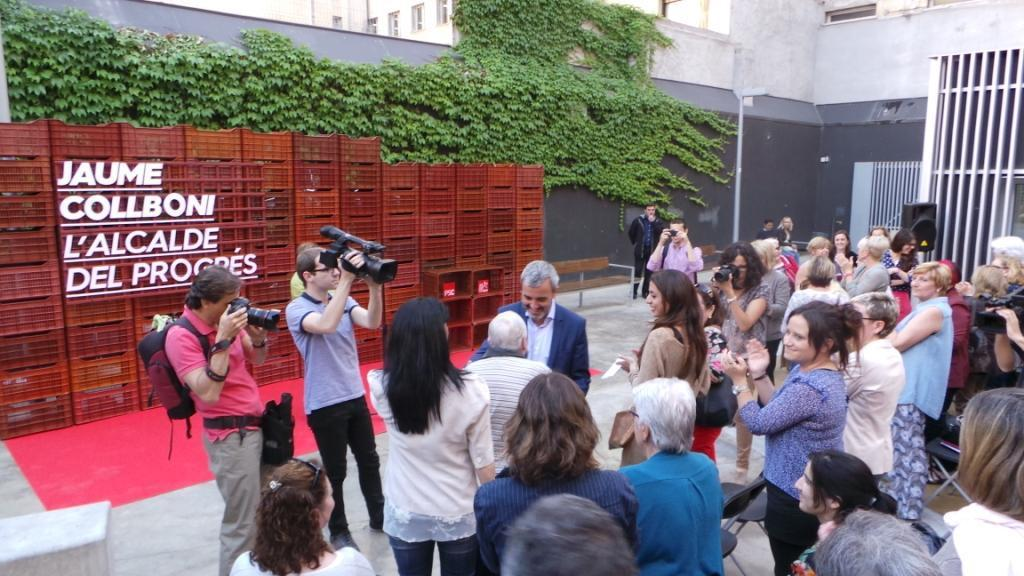How many people can be seen in the image? There are people in the image, but the exact number is not specified. What are some people doing in the image? Some people are holding cameras, which suggests they might be taking photographs. What type of structures are visible in the image? There are buildings in the image. What type of vegetation is present in the image? Creepers are present in the image. What type of objects can be seen in the image? Boxes are visible in the image. What type of openings are in the image? Windows are in the image. What type of barrier is present in the image? There is a grille in the image. What type of furniture is present in the image? Chairs are present in the image. What type of architectural element is visible in the image? The wall is visible in the image. What type of art can be seen on the property in the image? There is no mention of art or property in the image; it features people, buildings, creepers, boxes, windows, a grille, chairs, and a wall. What is the starting point for the event depicted in the image? There is no event or starting point mentioned in the image; it simply shows people, buildings, creepers, boxes, windows, a grille, chairs, and a wall. 